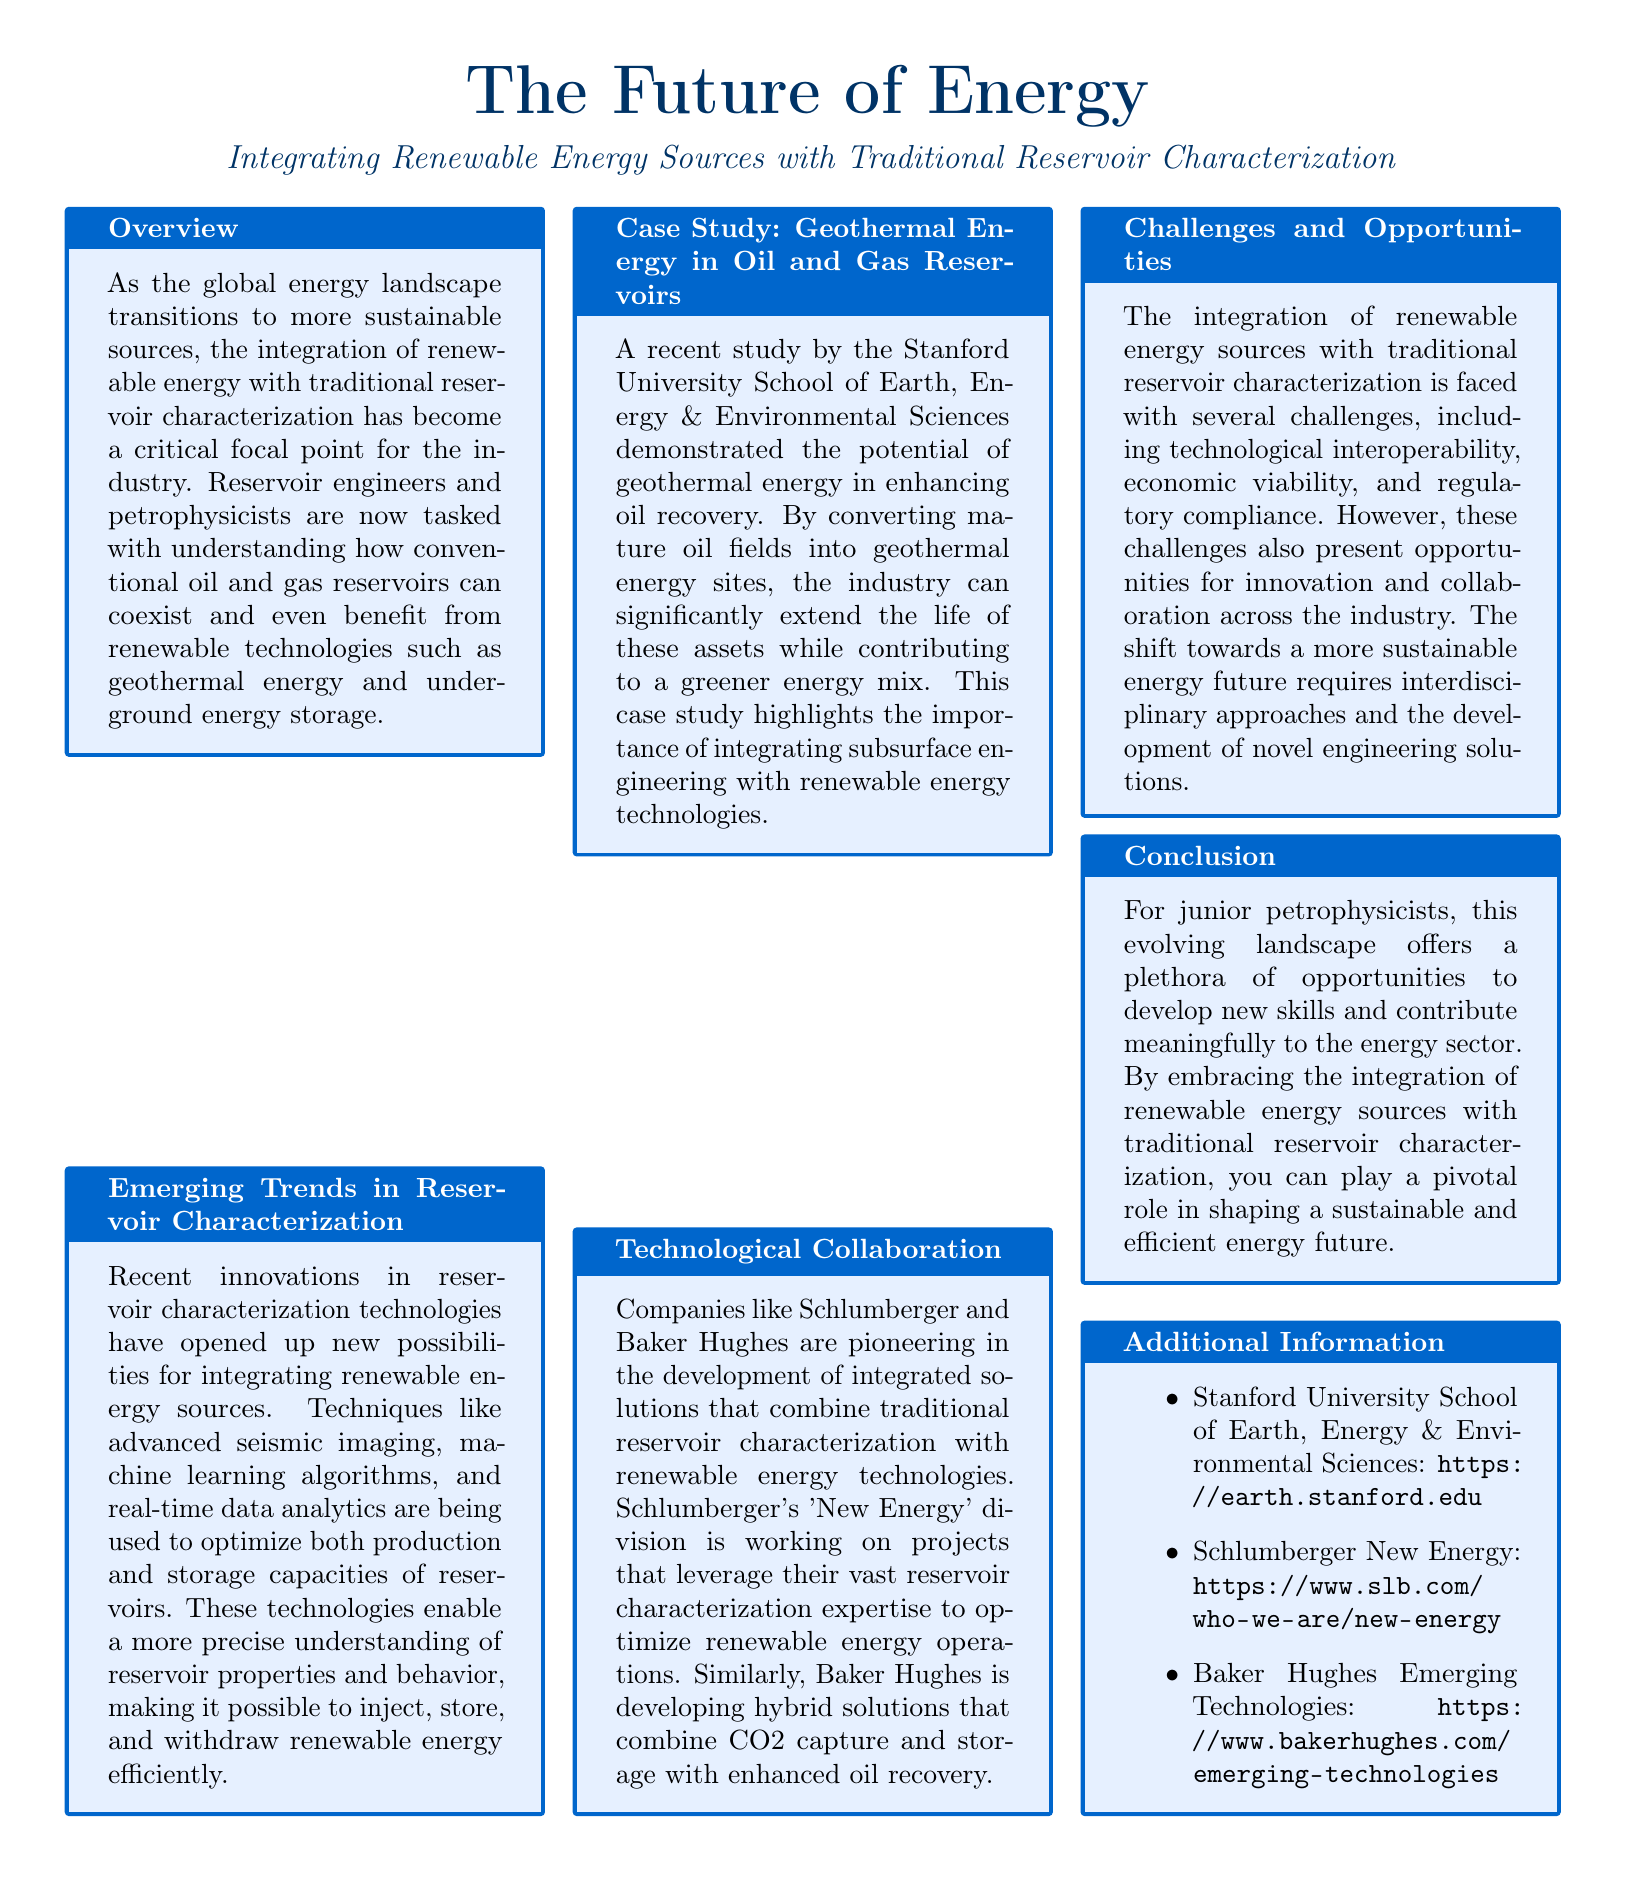what is the title of the document? The title is prominently featured at the top of the document and indicates the focus on energy integration.
Answer: The Future of Energy who conducted the recent geothermal energy case study? The document states that the study was performed by a specific academic institution.
Answer: Stanford University School of Earth, Energy & Environmental Sciences what are two companies mentioned as pioneers in technological collaboration? The document explicitly names companies working on integrated energy solutions, which are highlighted in one section.
Answer: Schlumberger and Baker Hughes what innovative technology is mentioned as improving reservoir characterization? The document lists several modern techniques that enhance the understanding of reservoirs.
Answer: Advanced seismic imaging what is one challenge faced in integrating renewable energy with traditional practices? The document outlines significant hurdles in the integration process, emphasizing one major issue.
Answer: Technological interoperability which division of Schlumberger focuses on renewable energy? The document provides the name of the specific division that deals with renewable energy efforts.
Answer: New Energy what is a key opportunity mentioned for junior petrophysicists? The conclusion of the document highlights a specific way for professionals to engage with new energy trends.
Answer: Developing new skills how can conventional reservoirs benefit from renewable technologies? The overview discusses the potential advantages of this integration, which is addressed in a specific context.
Answer: Coexist and benefit 